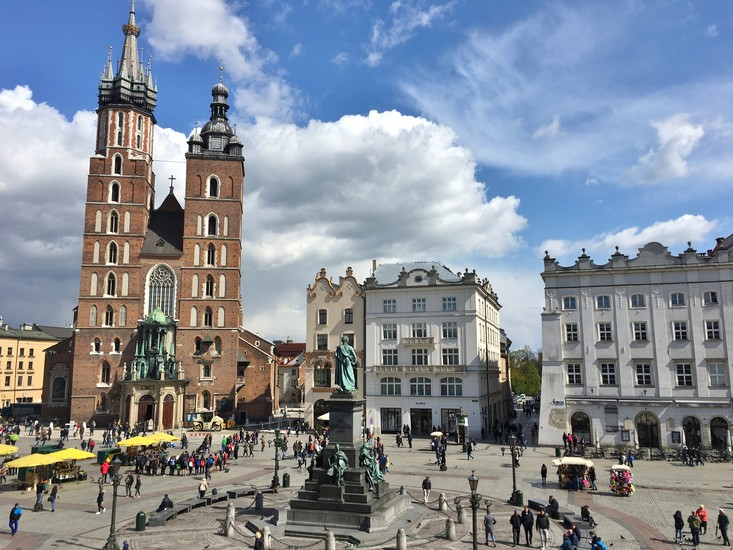Can you describe a casual scene one might witness here on a sunny day? On a sunny day, Krakow's Main Market Square buzzes with activity. Tourists wander around, admiring the picturesque architecture, while locals sit at outdoor cafes enjoying a cup of coffee or a meal. Street performers entertain passersby with music, dance, and art. Children run around chasing pigeons near the Adam Mickiewicz statue, and vendors at the market stalls offer a variety of goods, from fresh flowers to handmade crafts. The scene is one of joyous energy, with people savoring the lively atmosphere and beautiful surroundings. 